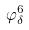Convert formula to latex. <formula><loc_0><loc_0><loc_500><loc_500>\varphi _ { \delta } ^ { 6 }</formula> 